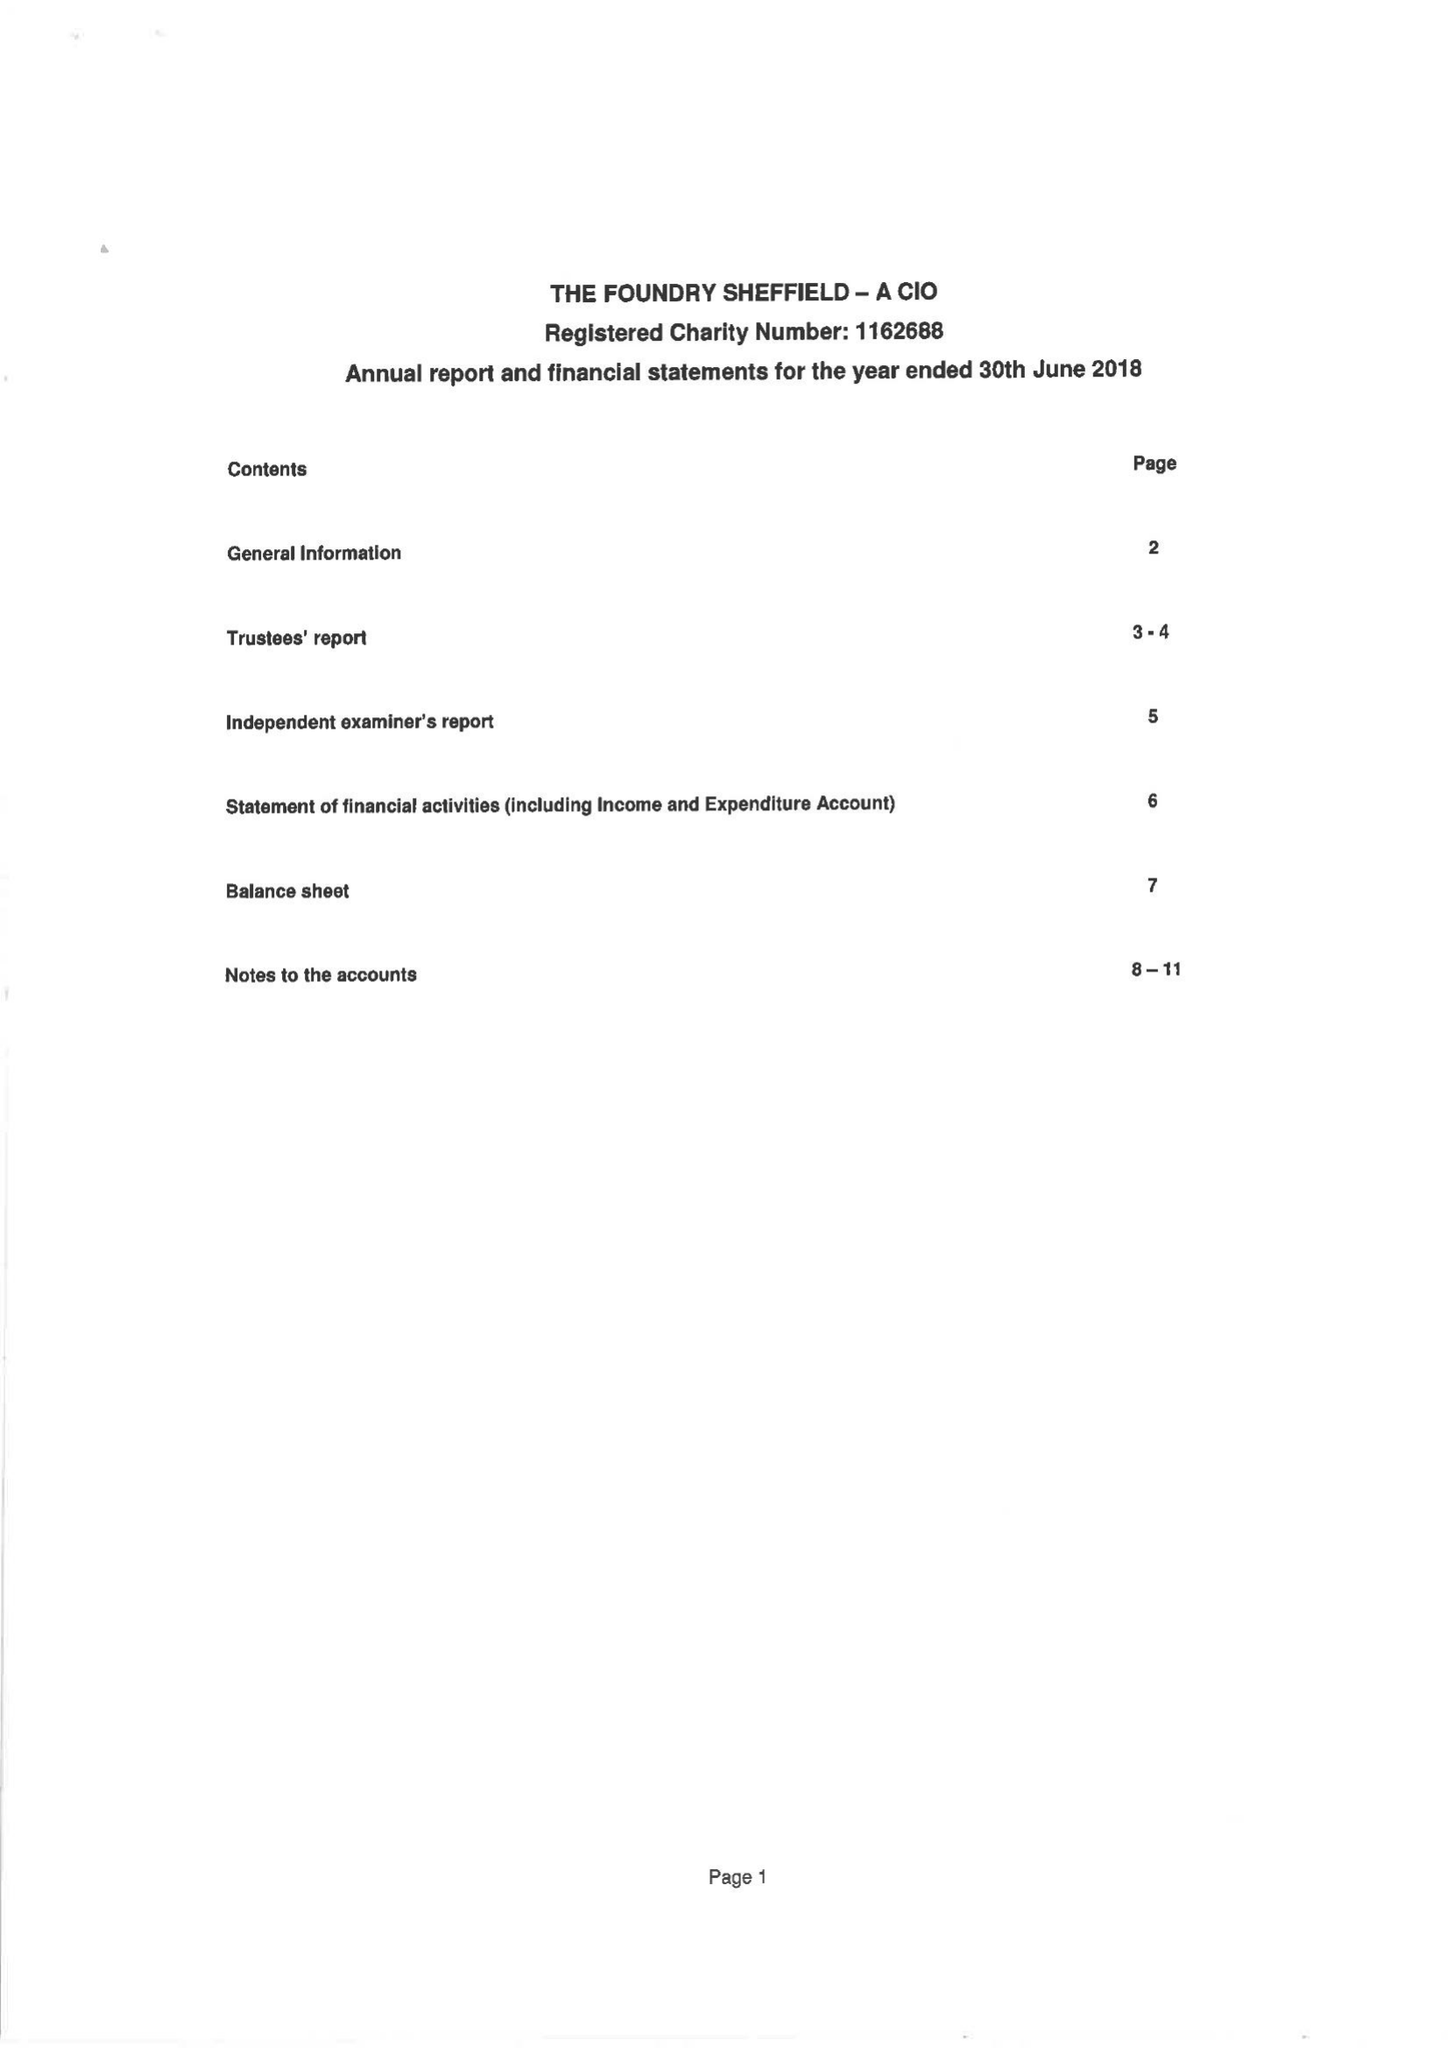What is the value for the address__post_town?
Answer the question using a single word or phrase. SHEFFIELD 